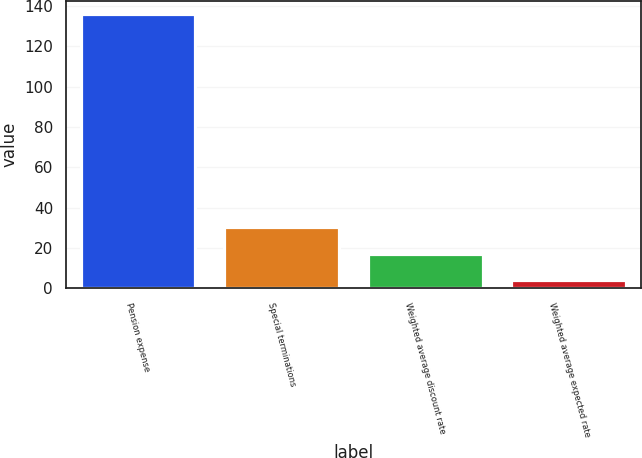<chart> <loc_0><loc_0><loc_500><loc_500><bar_chart><fcel>Pension expense<fcel>Special terminations<fcel>Weighted average discount rate<fcel>Weighted average expected rate<nl><fcel>135.9<fcel>30.3<fcel>17.1<fcel>3.9<nl></chart> 